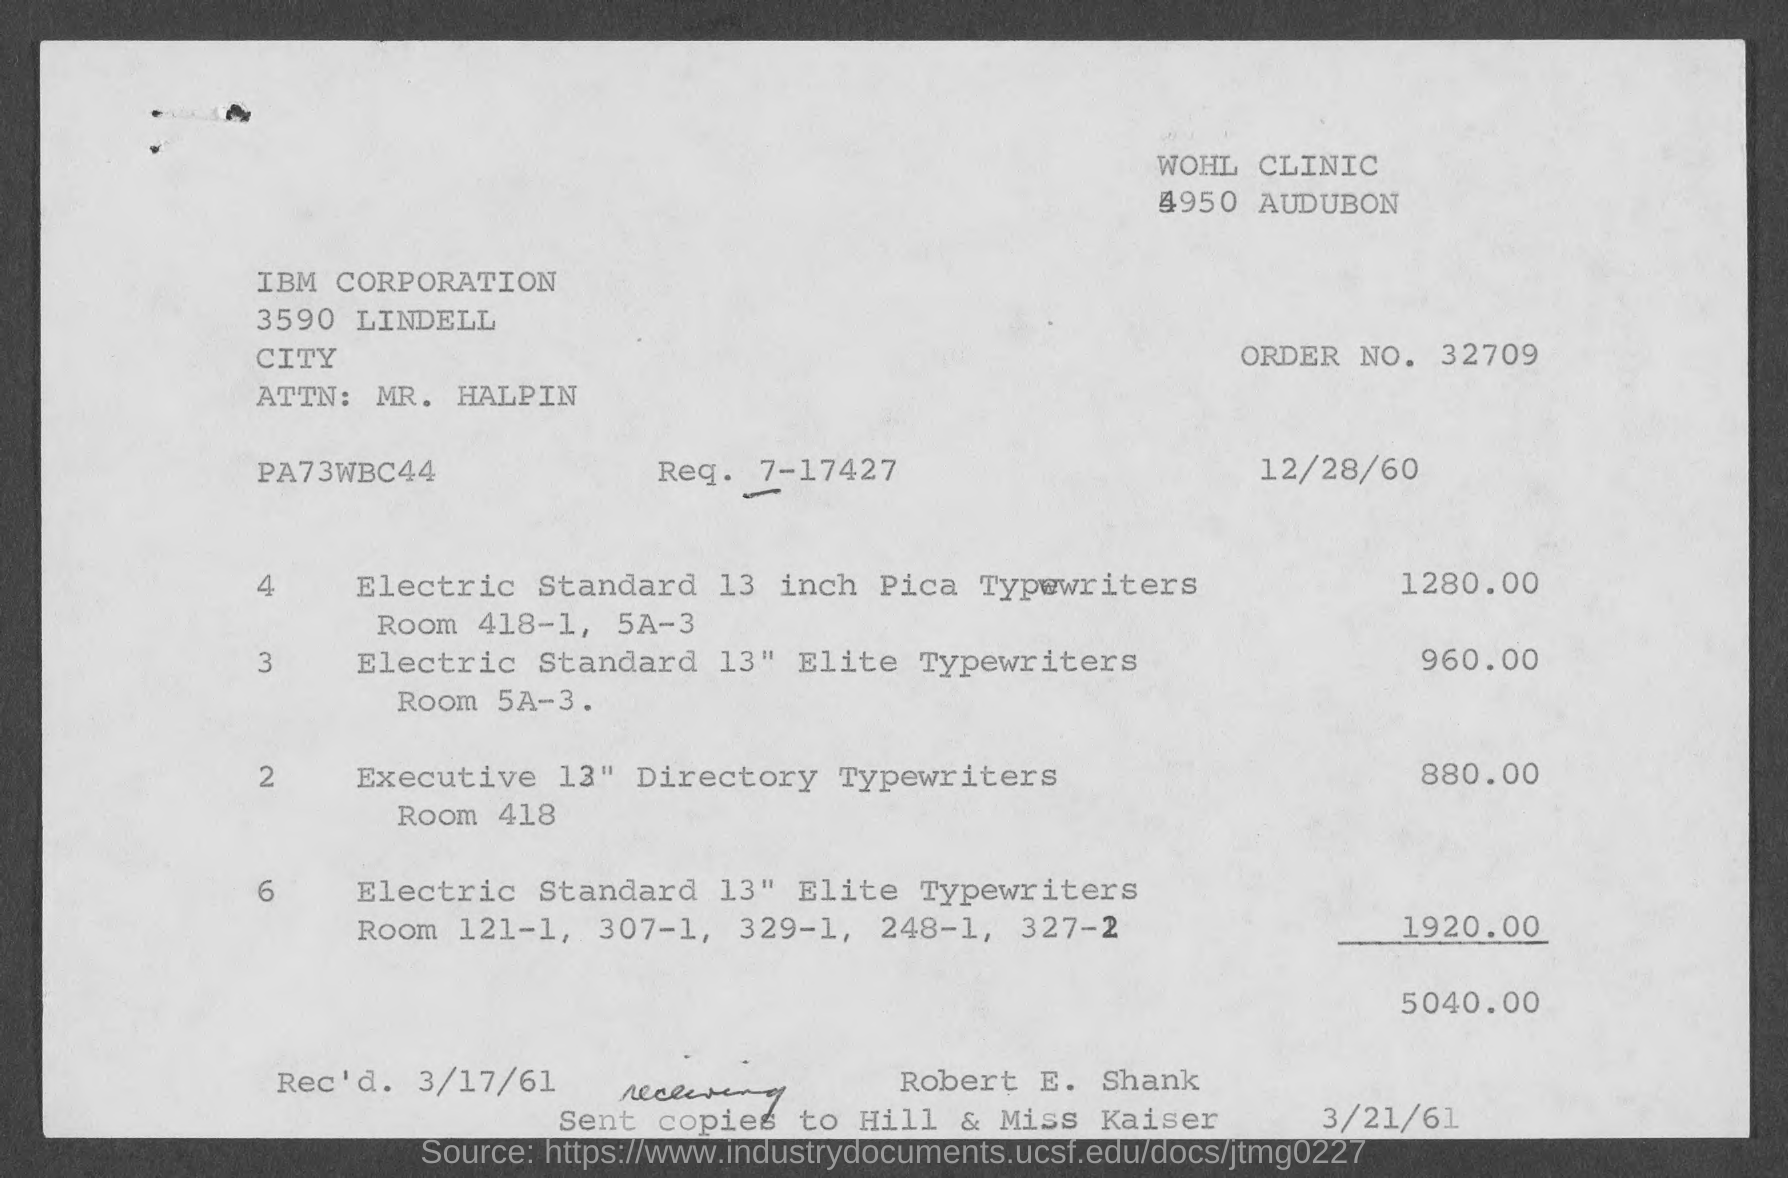Indicate a few pertinent items in this graphic. The order number is 32709. What is the request number? 